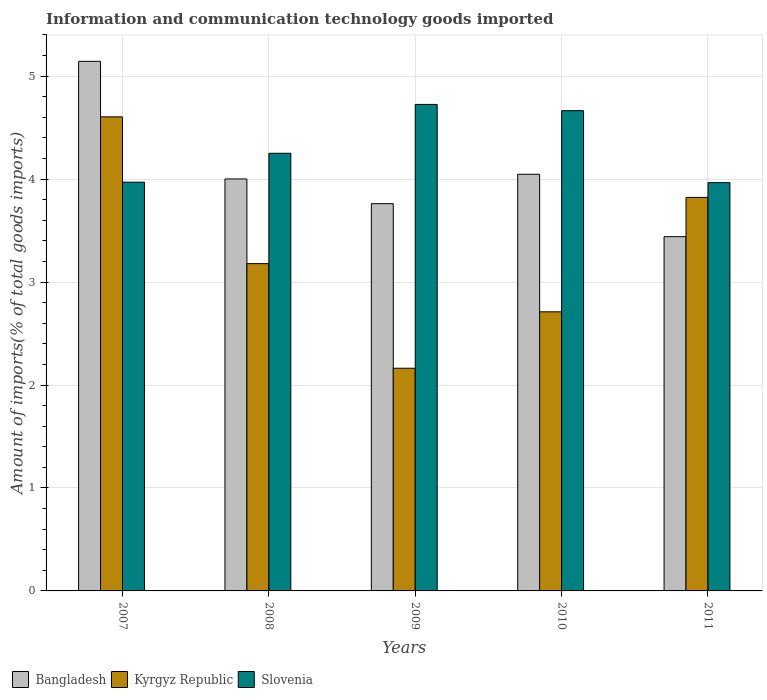How many different coloured bars are there?
Your answer should be compact. 3. Are the number of bars per tick equal to the number of legend labels?
Ensure brevity in your answer.  Yes. Are the number of bars on each tick of the X-axis equal?
Provide a succinct answer. Yes. How many bars are there on the 1st tick from the right?
Keep it short and to the point. 3. What is the label of the 1st group of bars from the left?
Make the answer very short. 2007. In how many cases, is the number of bars for a given year not equal to the number of legend labels?
Offer a terse response. 0. What is the amount of goods imported in Bangladesh in 2008?
Offer a very short reply. 4. Across all years, what is the maximum amount of goods imported in Slovenia?
Make the answer very short. 4.73. Across all years, what is the minimum amount of goods imported in Bangladesh?
Offer a very short reply. 3.44. What is the total amount of goods imported in Kyrgyz Republic in the graph?
Provide a succinct answer. 16.48. What is the difference between the amount of goods imported in Slovenia in 2008 and that in 2009?
Your response must be concise. -0.47. What is the difference between the amount of goods imported in Slovenia in 2011 and the amount of goods imported in Kyrgyz Republic in 2009?
Your answer should be compact. 1.8. What is the average amount of goods imported in Kyrgyz Republic per year?
Provide a short and direct response. 3.3. In the year 2009, what is the difference between the amount of goods imported in Kyrgyz Republic and amount of goods imported in Bangladesh?
Your answer should be very brief. -1.6. What is the ratio of the amount of goods imported in Kyrgyz Republic in 2007 to that in 2008?
Offer a terse response. 1.45. What is the difference between the highest and the second highest amount of goods imported in Kyrgyz Republic?
Offer a very short reply. 0.78. What is the difference between the highest and the lowest amount of goods imported in Bangladesh?
Make the answer very short. 1.7. What does the 1st bar from the left in 2009 represents?
Your answer should be very brief. Bangladesh. What does the 1st bar from the right in 2008 represents?
Keep it short and to the point. Slovenia. How many years are there in the graph?
Offer a very short reply. 5. What is the difference between two consecutive major ticks on the Y-axis?
Your answer should be very brief. 1. Are the values on the major ticks of Y-axis written in scientific E-notation?
Offer a terse response. No. Does the graph contain any zero values?
Your response must be concise. No. Does the graph contain grids?
Offer a terse response. Yes. How many legend labels are there?
Provide a short and direct response. 3. What is the title of the graph?
Keep it short and to the point. Information and communication technology goods imported. Does "Ecuador" appear as one of the legend labels in the graph?
Keep it short and to the point. No. What is the label or title of the X-axis?
Your answer should be compact. Years. What is the label or title of the Y-axis?
Your answer should be compact. Amount of imports(% of total goods imports). What is the Amount of imports(% of total goods imports) of Bangladesh in 2007?
Make the answer very short. 5.14. What is the Amount of imports(% of total goods imports) of Kyrgyz Republic in 2007?
Provide a succinct answer. 4.6. What is the Amount of imports(% of total goods imports) of Slovenia in 2007?
Your response must be concise. 3.97. What is the Amount of imports(% of total goods imports) in Bangladesh in 2008?
Offer a terse response. 4. What is the Amount of imports(% of total goods imports) of Kyrgyz Republic in 2008?
Offer a terse response. 3.18. What is the Amount of imports(% of total goods imports) of Slovenia in 2008?
Provide a short and direct response. 4.25. What is the Amount of imports(% of total goods imports) of Bangladesh in 2009?
Offer a terse response. 3.76. What is the Amount of imports(% of total goods imports) in Kyrgyz Republic in 2009?
Keep it short and to the point. 2.16. What is the Amount of imports(% of total goods imports) in Slovenia in 2009?
Ensure brevity in your answer.  4.73. What is the Amount of imports(% of total goods imports) in Bangladesh in 2010?
Offer a terse response. 4.05. What is the Amount of imports(% of total goods imports) of Kyrgyz Republic in 2010?
Provide a short and direct response. 2.71. What is the Amount of imports(% of total goods imports) in Slovenia in 2010?
Offer a very short reply. 4.66. What is the Amount of imports(% of total goods imports) of Bangladesh in 2011?
Provide a succinct answer. 3.44. What is the Amount of imports(% of total goods imports) in Kyrgyz Republic in 2011?
Ensure brevity in your answer.  3.82. What is the Amount of imports(% of total goods imports) in Slovenia in 2011?
Your answer should be very brief. 3.97. Across all years, what is the maximum Amount of imports(% of total goods imports) in Bangladesh?
Your response must be concise. 5.14. Across all years, what is the maximum Amount of imports(% of total goods imports) of Kyrgyz Republic?
Ensure brevity in your answer.  4.6. Across all years, what is the maximum Amount of imports(% of total goods imports) of Slovenia?
Your answer should be compact. 4.73. Across all years, what is the minimum Amount of imports(% of total goods imports) of Bangladesh?
Your answer should be compact. 3.44. Across all years, what is the minimum Amount of imports(% of total goods imports) in Kyrgyz Republic?
Your response must be concise. 2.16. Across all years, what is the minimum Amount of imports(% of total goods imports) in Slovenia?
Offer a very short reply. 3.97. What is the total Amount of imports(% of total goods imports) in Bangladesh in the graph?
Offer a very short reply. 20.39. What is the total Amount of imports(% of total goods imports) in Kyrgyz Republic in the graph?
Provide a short and direct response. 16.48. What is the total Amount of imports(% of total goods imports) of Slovenia in the graph?
Give a very brief answer. 21.58. What is the difference between the Amount of imports(% of total goods imports) of Bangladesh in 2007 and that in 2008?
Give a very brief answer. 1.14. What is the difference between the Amount of imports(% of total goods imports) of Kyrgyz Republic in 2007 and that in 2008?
Ensure brevity in your answer.  1.43. What is the difference between the Amount of imports(% of total goods imports) in Slovenia in 2007 and that in 2008?
Your response must be concise. -0.28. What is the difference between the Amount of imports(% of total goods imports) in Bangladesh in 2007 and that in 2009?
Your answer should be compact. 1.38. What is the difference between the Amount of imports(% of total goods imports) of Kyrgyz Republic in 2007 and that in 2009?
Offer a terse response. 2.44. What is the difference between the Amount of imports(% of total goods imports) of Slovenia in 2007 and that in 2009?
Keep it short and to the point. -0.76. What is the difference between the Amount of imports(% of total goods imports) in Bangladesh in 2007 and that in 2010?
Offer a very short reply. 1.1. What is the difference between the Amount of imports(% of total goods imports) in Kyrgyz Republic in 2007 and that in 2010?
Your answer should be very brief. 1.89. What is the difference between the Amount of imports(% of total goods imports) of Slovenia in 2007 and that in 2010?
Ensure brevity in your answer.  -0.69. What is the difference between the Amount of imports(% of total goods imports) in Bangladesh in 2007 and that in 2011?
Ensure brevity in your answer.  1.7. What is the difference between the Amount of imports(% of total goods imports) of Kyrgyz Republic in 2007 and that in 2011?
Keep it short and to the point. 0.78. What is the difference between the Amount of imports(% of total goods imports) in Slovenia in 2007 and that in 2011?
Offer a very short reply. 0. What is the difference between the Amount of imports(% of total goods imports) in Bangladesh in 2008 and that in 2009?
Your answer should be very brief. 0.24. What is the difference between the Amount of imports(% of total goods imports) in Kyrgyz Republic in 2008 and that in 2009?
Ensure brevity in your answer.  1.02. What is the difference between the Amount of imports(% of total goods imports) of Slovenia in 2008 and that in 2009?
Your response must be concise. -0.47. What is the difference between the Amount of imports(% of total goods imports) in Bangladesh in 2008 and that in 2010?
Give a very brief answer. -0.05. What is the difference between the Amount of imports(% of total goods imports) of Kyrgyz Republic in 2008 and that in 2010?
Ensure brevity in your answer.  0.47. What is the difference between the Amount of imports(% of total goods imports) in Slovenia in 2008 and that in 2010?
Make the answer very short. -0.41. What is the difference between the Amount of imports(% of total goods imports) of Bangladesh in 2008 and that in 2011?
Offer a very short reply. 0.56. What is the difference between the Amount of imports(% of total goods imports) of Kyrgyz Republic in 2008 and that in 2011?
Provide a succinct answer. -0.64. What is the difference between the Amount of imports(% of total goods imports) of Slovenia in 2008 and that in 2011?
Offer a terse response. 0.28. What is the difference between the Amount of imports(% of total goods imports) in Bangladesh in 2009 and that in 2010?
Provide a short and direct response. -0.29. What is the difference between the Amount of imports(% of total goods imports) of Kyrgyz Republic in 2009 and that in 2010?
Offer a very short reply. -0.55. What is the difference between the Amount of imports(% of total goods imports) in Slovenia in 2009 and that in 2010?
Provide a succinct answer. 0.06. What is the difference between the Amount of imports(% of total goods imports) of Bangladesh in 2009 and that in 2011?
Keep it short and to the point. 0.32. What is the difference between the Amount of imports(% of total goods imports) in Kyrgyz Republic in 2009 and that in 2011?
Your response must be concise. -1.66. What is the difference between the Amount of imports(% of total goods imports) in Slovenia in 2009 and that in 2011?
Your response must be concise. 0.76. What is the difference between the Amount of imports(% of total goods imports) in Bangladesh in 2010 and that in 2011?
Provide a short and direct response. 0.61. What is the difference between the Amount of imports(% of total goods imports) in Kyrgyz Republic in 2010 and that in 2011?
Your answer should be compact. -1.11. What is the difference between the Amount of imports(% of total goods imports) of Slovenia in 2010 and that in 2011?
Offer a terse response. 0.7. What is the difference between the Amount of imports(% of total goods imports) of Bangladesh in 2007 and the Amount of imports(% of total goods imports) of Kyrgyz Republic in 2008?
Ensure brevity in your answer.  1.96. What is the difference between the Amount of imports(% of total goods imports) in Bangladesh in 2007 and the Amount of imports(% of total goods imports) in Slovenia in 2008?
Make the answer very short. 0.89. What is the difference between the Amount of imports(% of total goods imports) in Kyrgyz Republic in 2007 and the Amount of imports(% of total goods imports) in Slovenia in 2008?
Provide a succinct answer. 0.35. What is the difference between the Amount of imports(% of total goods imports) in Bangladesh in 2007 and the Amount of imports(% of total goods imports) in Kyrgyz Republic in 2009?
Make the answer very short. 2.98. What is the difference between the Amount of imports(% of total goods imports) in Bangladesh in 2007 and the Amount of imports(% of total goods imports) in Slovenia in 2009?
Your response must be concise. 0.42. What is the difference between the Amount of imports(% of total goods imports) in Kyrgyz Republic in 2007 and the Amount of imports(% of total goods imports) in Slovenia in 2009?
Offer a very short reply. -0.12. What is the difference between the Amount of imports(% of total goods imports) of Bangladesh in 2007 and the Amount of imports(% of total goods imports) of Kyrgyz Republic in 2010?
Provide a short and direct response. 2.43. What is the difference between the Amount of imports(% of total goods imports) in Bangladesh in 2007 and the Amount of imports(% of total goods imports) in Slovenia in 2010?
Your response must be concise. 0.48. What is the difference between the Amount of imports(% of total goods imports) of Kyrgyz Republic in 2007 and the Amount of imports(% of total goods imports) of Slovenia in 2010?
Offer a terse response. -0.06. What is the difference between the Amount of imports(% of total goods imports) in Bangladesh in 2007 and the Amount of imports(% of total goods imports) in Kyrgyz Republic in 2011?
Make the answer very short. 1.32. What is the difference between the Amount of imports(% of total goods imports) in Bangladesh in 2007 and the Amount of imports(% of total goods imports) in Slovenia in 2011?
Offer a very short reply. 1.18. What is the difference between the Amount of imports(% of total goods imports) of Kyrgyz Republic in 2007 and the Amount of imports(% of total goods imports) of Slovenia in 2011?
Offer a terse response. 0.64. What is the difference between the Amount of imports(% of total goods imports) of Bangladesh in 2008 and the Amount of imports(% of total goods imports) of Kyrgyz Republic in 2009?
Ensure brevity in your answer.  1.84. What is the difference between the Amount of imports(% of total goods imports) of Bangladesh in 2008 and the Amount of imports(% of total goods imports) of Slovenia in 2009?
Provide a short and direct response. -0.72. What is the difference between the Amount of imports(% of total goods imports) of Kyrgyz Republic in 2008 and the Amount of imports(% of total goods imports) of Slovenia in 2009?
Your answer should be compact. -1.55. What is the difference between the Amount of imports(% of total goods imports) in Bangladesh in 2008 and the Amount of imports(% of total goods imports) in Kyrgyz Republic in 2010?
Your response must be concise. 1.29. What is the difference between the Amount of imports(% of total goods imports) in Bangladesh in 2008 and the Amount of imports(% of total goods imports) in Slovenia in 2010?
Keep it short and to the point. -0.66. What is the difference between the Amount of imports(% of total goods imports) in Kyrgyz Republic in 2008 and the Amount of imports(% of total goods imports) in Slovenia in 2010?
Keep it short and to the point. -1.49. What is the difference between the Amount of imports(% of total goods imports) in Bangladesh in 2008 and the Amount of imports(% of total goods imports) in Kyrgyz Republic in 2011?
Offer a terse response. 0.18. What is the difference between the Amount of imports(% of total goods imports) in Bangladesh in 2008 and the Amount of imports(% of total goods imports) in Slovenia in 2011?
Your answer should be very brief. 0.04. What is the difference between the Amount of imports(% of total goods imports) of Kyrgyz Republic in 2008 and the Amount of imports(% of total goods imports) of Slovenia in 2011?
Keep it short and to the point. -0.79. What is the difference between the Amount of imports(% of total goods imports) of Bangladesh in 2009 and the Amount of imports(% of total goods imports) of Kyrgyz Republic in 2010?
Your answer should be compact. 1.05. What is the difference between the Amount of imports(% of total goods imports) in Bangladesh in 2009 and the Amount of imports(% of total goods imports) in Slovenia in 2010?
Your answer should be very brief. -0.9. What is the difference between the Amount of imports(% of total goods imports) of Kyrgyz Republic in 2009 and the Amount of imports(% of total goods imports) of Slovenia in 2010?
Your answer should be compact. -2.5. What is the difference between the Amount of imports(% of total goods imports) of Bangladesh in 2009 and the Amount of imports(% of total goods imports) of Kyrgyz Republic in 2011?
Offer a very short reply. -0.06. What is the difference between the Amount of imports(% of total goods imports) of Bangladesh in 2009 and the Amount of imports(% of total goods imports) of Slovenia in 2011?
Give a very brief answer. -0.2. What is the difference between the Amount of imports(% of total goods imports) in Kyrgyz Republic in 2009 and the Amount of imports(% of total goods imports) in Slovenia in 2011?
Offer a terse response. -1.8. What is the difference between the Amount of imports(% of total goods imports) of Bangladesh in 2010 and the Amount of imports(% of total goods imports) of Kyrgyz Republic in 2011?
Keep it short and to the point. 0.22. What is the difference between the Amount of imports(% of total goods imports) in Bangladesh in 2010 and the Amount of imports(% of total goods imports) in Slovenia in 2011?
Provide a succinct answer. 0.08. What is the difference between the Amount of imports(% of total goods imports) of Kyrgyz Republic in 2010 and the Amount of imports(% of total goods imports) of Slovenia in 2011?
Provide a succinct answer. -1.25. What is the average Amount of imports(% of total goods imports) of Bangladesh per year?
Offer a very short reply. 4.08. What is the average Amount of imports(% of total goods imports) in Kyrgyz Republic per year?
Provide a short and direct response. 3.3. What is the average Amount of imports(% of total goods imports) of Slovenia per year?
Provide a short and direct response. 4.32. In the year 2007, what is the difference between the Amount of imports(% of total goods imports) in Bangladesh and Amount of imports(% of total goods imports) in Kyrgyz Republic?
Make the answer very short. 0.54. In the year 2007, what is the difference between the Amount of imports(% of total goods imports) of Bangladesh and Amount of imports(% of total goods imports) of Slovenia?
Your response must be concise. 1.17. In the year 2007, what is the difference between the Amount of imports(% of total goods imports) in Kyrgyz Republic and Amount of imports(% of total goods imports) in Slovenia?
Offer a terse response. 0.63. In the year 2008, what is the difference between the Amount of imports(% of total goods imports) of Bangladesh and Amount of imports(% of total goods imports) of Kyrgyz Republic?
Ensure brevity in your answer.  0.82. In the year 2008, what is the difference between the Amount of imports(% of total goods imports) of Bangladesh and Amount of imports(% of total goods imports) of Slovenia?
Your answer should be compact. -0.25. In the year 2008, what is the difference between the Amount of imports(% of total goods imports) of Kyrgyz Republic and Amount of imports(% of total goods imports) of Slovenia?
Make the answer very short. -1.07. In the year 2009, what is the difference between the Amount of imports(% of total goods imports) in Bangladesh and Amount of imports(% of total goods imports) in Kyrgyz Republic?
Your answer should be compact. 1.6. In the year 2009, what is the difference between the Amount of imports(% of total goods imports) in Bangladesh and Amount of imports(% of total goods imports) in Slovenia?
Give a very brief answer. -0.96. In the year 2009, what is the difference between the Amount of imports(% of total goods imports) in Kyrgyz Republic and Amount of imports(% of total goods imports) in Slovenia?
Ensure brevity in your answer.  -2.56. In the year 2010, what is the difference between the Amount of imports(% of total goods imports) in Bangladesh and Amount of imports(% of total goods imports) in Kyrgyz Republic?
Ensure brevity in your answer.  1.34. In the year 2010, what is the difference between the Amount of imports(% of total goods imports) of Bangladesh and Amount of imports(% of total goods imports) of Slovenia?
Provide a succinct answer. -0.62. In the year 2010, what is the difference between the Amount of imports(% of total goods imports) in Kyrgyz Republic and Amount of imports(% of total goods imports) in Slovenia?
Give a very brief answer. -1.95. In the year 2011, what is the difference between the Amount of imports(% of total goods imports) of Bangladesh and Amount of imports(% of total goods imports) of Kyrgyz Republic?
Ensure brevity in your answer.  -0.38. In the year 2011, what is the difference between the Amount of imports(% of total goods imports) of Bangladesh and Amount of imports(% of total goods imports) of Slovenia?
Give a very brief answer. -0.53. In the year 2011, what is the difference between the Amount of imports(% of total goods imports) of Kyrgyz Republic and Amount of imports(% of total goods imports) of Slovenia?
Provide a succinct answer. -0.14. What is the ratio of the Amount of imports(% of total goods imports) of Bangladesh in 2007 to that in 2008?
Your answer should be very brief. 1.29. What is the ratio of the Amount of imports(% of total goods imports) of Kyrgyz Republic in 2007 to that in 2008?
Provide a succinct answer. 1.45. What is the ratio of the Amount of imports(% of total goods imports) of Slovenia in 2007 to that in 2008?
Provide a succinct answer. 0.93. What is the ratio of the Amount of imports(% of total goods imports) of Bangladesh in 2007 to that in 2009?
Provide a short and direct response. 1.37. What is the ratio of the Amount of imports(% of total goods imports) in Kyrgyz Republic in 2007 to that in 2009?
Your response must be concise. 2.13. What is the ratio of the Amount of imports(% of total goods imports) in Slovenia in 2007 to that in 2009?
Provide a short and direct response. 0.84. What is the ratio of the Amount of imports(% of total goods imports) in Bangladesh in 2007 to that in 2010?
Offer a very short reply. 1.27. What is the ratio of the Amount of imports(% of total goods imports) in Kyrgyz Republic in 2007 to that in 2010?
Make the answer very short. 1.7. What is the ratio of the Amount of imports(% of total goods imports) of Slovenia in 2007 to that in 2010?
Provide a short and direct response. 0.85. What is the ratio of the Amount of imports(% of total goods imports) in Bangladesh in 2007 to that in 2011?
Offer a very short reply. 1.49. What is the ratio of the Amount of imports(% of total goods imports) of Kyrgyz Republic in 2007 to that in 2011?
Provide a short and direct response. 1.2. What is the ratio of the Amount of imports(% of total goods imports) of Slovenia in 2007 to that in 2011?
Your response must be concise. 1. What is the ratio of the Amount of imports(% of total goods imports) in Bangladesh in 2008 to that in 2009?
Keep it short and to the point. 1.06. What is the ratio of the Amount of imports(% of total goods imports) in Kyrgyz Republic in 2008 to that in 2009?
Offer a very short reply. 1.47. What is the ratio of the Amount of imports(% of total goods imports) in Slovenia in 2008 to that in 2009?
Your response must be concise. 0.9. What is the ratio of the Amount of imports(% of total goods imports) in Bangladesh in 2008 to that in 2010?
Give a very brief answer. 0.99. What is the ratio of the Amount of imports(% of total goods imports) of Kyrgyz Republic in 2008 to that in 2010?
Your response must be concise. 1.17. What is the ratio of the Amount of imports(% of total goods imports) of Slovenia in 2008 to that in 2010?
Provide a succinct answer. 0.91. What is the ratio of the Amount of imports(% of total goods imports) of Bangladesh in 2008 to that in 2011?
Give a very brief answer. 1.16. What is the ratio of the Amount of imports(% of total goods imports) in Kyrgyz Republic in 2008 to that in 2011?
Offer a terse response. 0.83. What is the ratio of the Amount of imports(% of total goods imports) of Slovenia in 2008 to that in 2011?
Your answer should be very brief. 1.07. What is the ratio of the Amount of imports(% of total goods imports) of Bangladesh in 2009 to that in 2010?
Offer a terse response. 0.93. What is the ratio of the Amount of imports(% of total goods imports) of Kyrgyz Republic in 2009 to that in 2010?
Your answer should be very brief. 0.8. What is the ratio of the Amount of imports(% of total goods imports) in Bangladesh in 2009 to that in 2011?
Keep it short and to the point. 1.09. What is the ratio of the Amount of imports(% of total goods imports) in Kyrgyz Republic in 2009 to that in 2011?
Make the answer very short. 0.57. What is the ratio of the Amount of imports(% of total goods imports) in Slovenia in 2009 to that in 2011?
Ensure brevity in your answer.  1.19. What is the ratio of the Amount of imports(% of total goods imports) of Bangladesh in 2010 to that in 2011?
Offer a terse response. 1.18. What is the ratio of the Amount of imports(% of total goods imports) of Kyrgyz Republic in 2010 to that in 2011?
Ensure brevity in your answer.  0.71. What is the ratio of the Amount of imports(% of total goods imports) of Slovenia in 2010 to that in 2011?
Ensure brevity in your answer.  1.18. What is the difference between the highest and the second highest Amount of imports(% of total goods imports) in Bangladesh?
Provide a short and direct response. 1.1. What is the difference between the highest and the second highest Amount of imports(% of total goods imports) of Kyrgyz Republic?
Your answer should be very brief. 0.78. What is the difference between the highest and the second highest Amount of imports(% of total goods imports) of Slovenia?
Ensure brevity in your answer.  0.06. What is the difference between the highest and the lowest Amount of imports(% of total goods imports) of Bangladesh?
Make the answer very short. 1.7. What is the difference between the highest and the lowest Amount of imports(% of total goods imports) in Kyrgyz Republic?
Offer a terse response. 2.44. What is the difference between the highest and the lowest Amount of imports(% of total goods imports) in Slovenia?
Your answer should be compact. 0.76. 